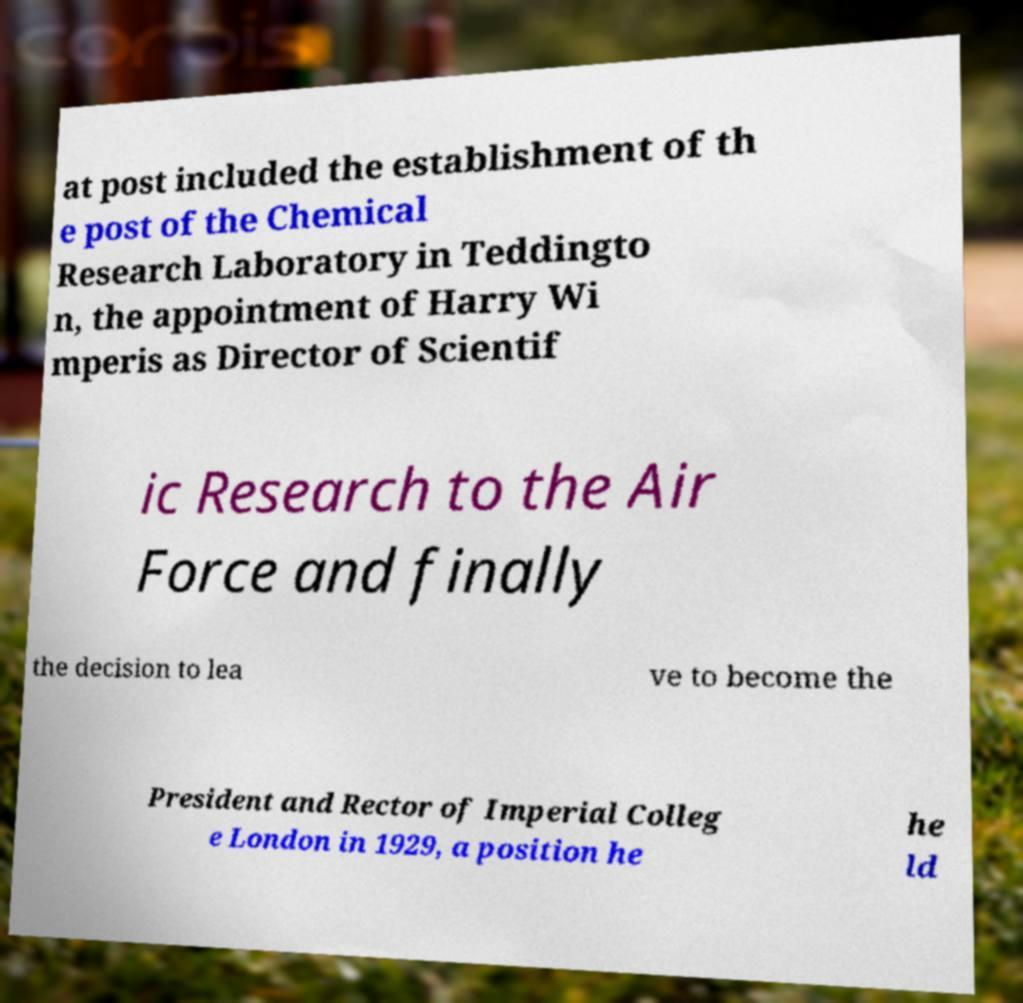I need the written content from this picture converted into text. Can you do that? at post included the establishment of th e post of the Chemical Research Laboratory in Teddingto n, the appointment of Harry Wi mperis as Director of Scientif ic Research to the Air Force and finally the decision to lea ve to become the President and Rector of Imperial Colleg e London in 1929, a position he he ld 